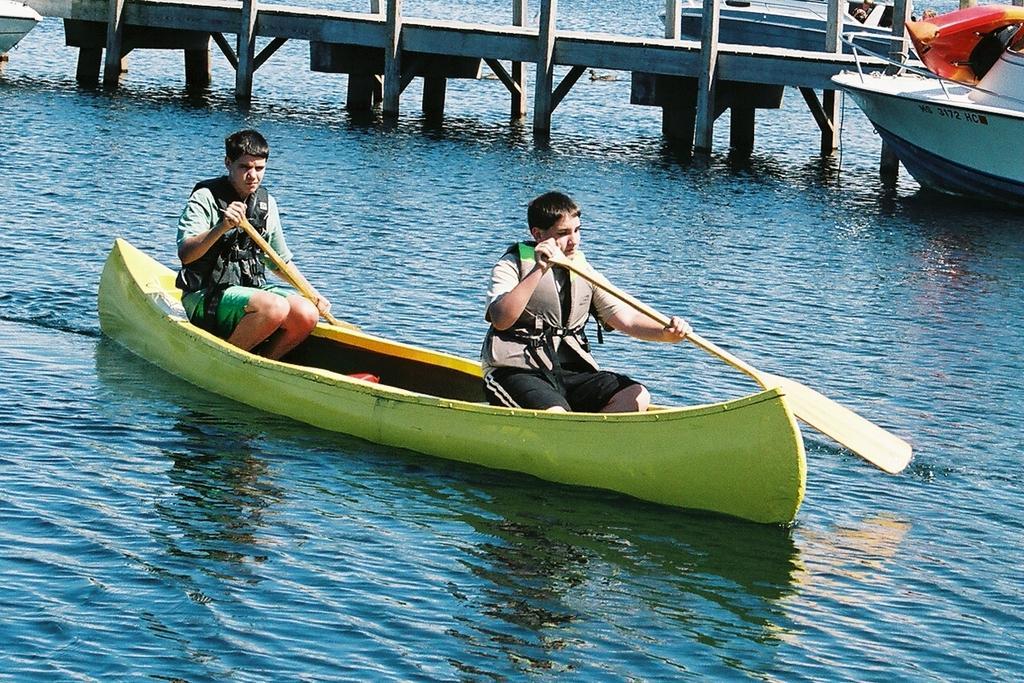How would you summarize this image in a sentence or two? In this image I can see a boat which is blue in color on the surface of the water and two persons sitting in a boat holding paddles in their hands. In the background I can see a bridge and two boats tied to the bridge. 